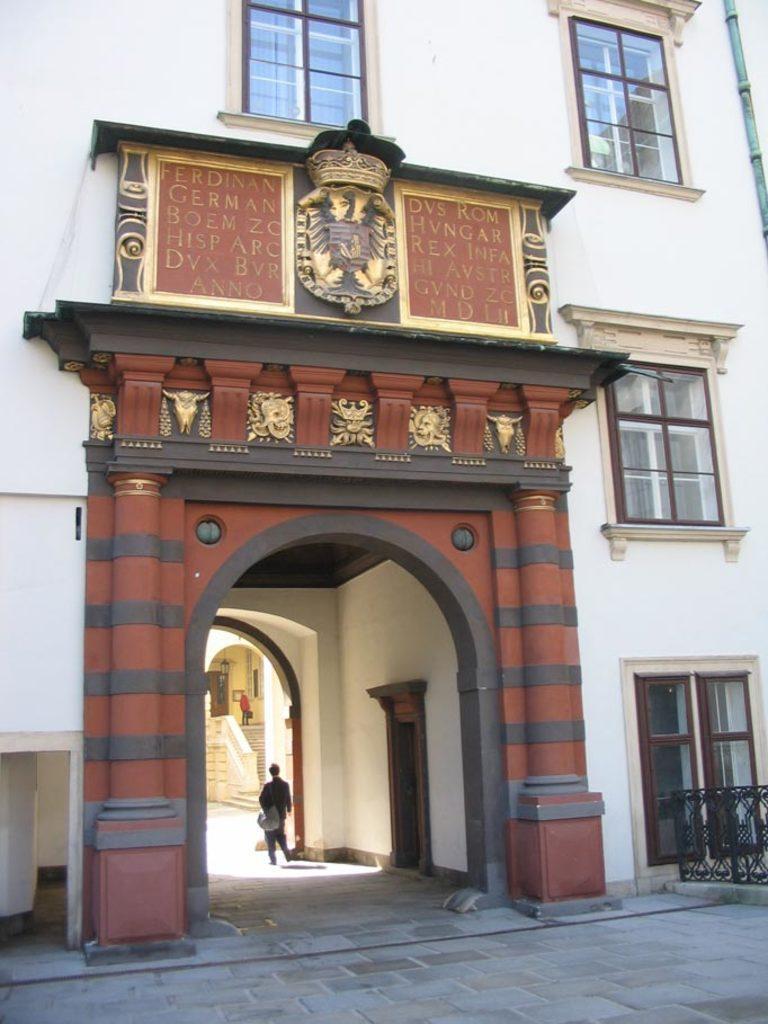Describe this image in one or two sentences. In this image we can see a building, boards, windows, doors, and two people. 